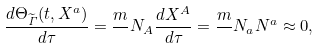Convert formula to latex. <formula><loc_0><loc_0><loc_500><loc_500>\frac { d \Theta _ { \widetilde { \mathit \Gamma } } ( t , X ^ { a } ) } { d \tau } = \frac { m } { } N _ { A } \frac { d X ^ { A } } { d \tau } = \frac { m } { } N _ { a } N ^ { a } \approx 0 ,</formula> 